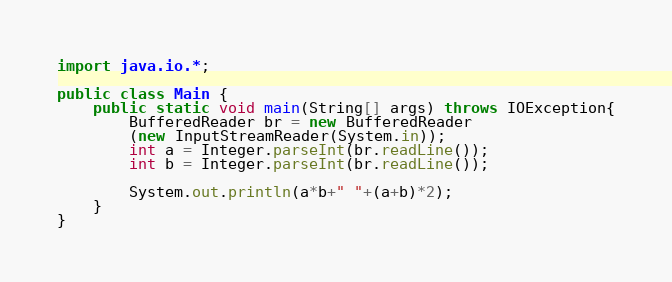<code> <loc_0><loc_0><loc_500><loc_500><_Java_>import java.io.*;

public class Main {
    public static void main(String[] args) throws IOException{
    	BufferedReader br = new BufferedReader
    	(new InputStreamReader(System.in));
    	int a = Integer.parseInt(br.readLine());
    	int b = Integer.parseInt(br.readLine());

    	System.out.println(a*b+" "+(a+b)*2);
    }
}</code> 